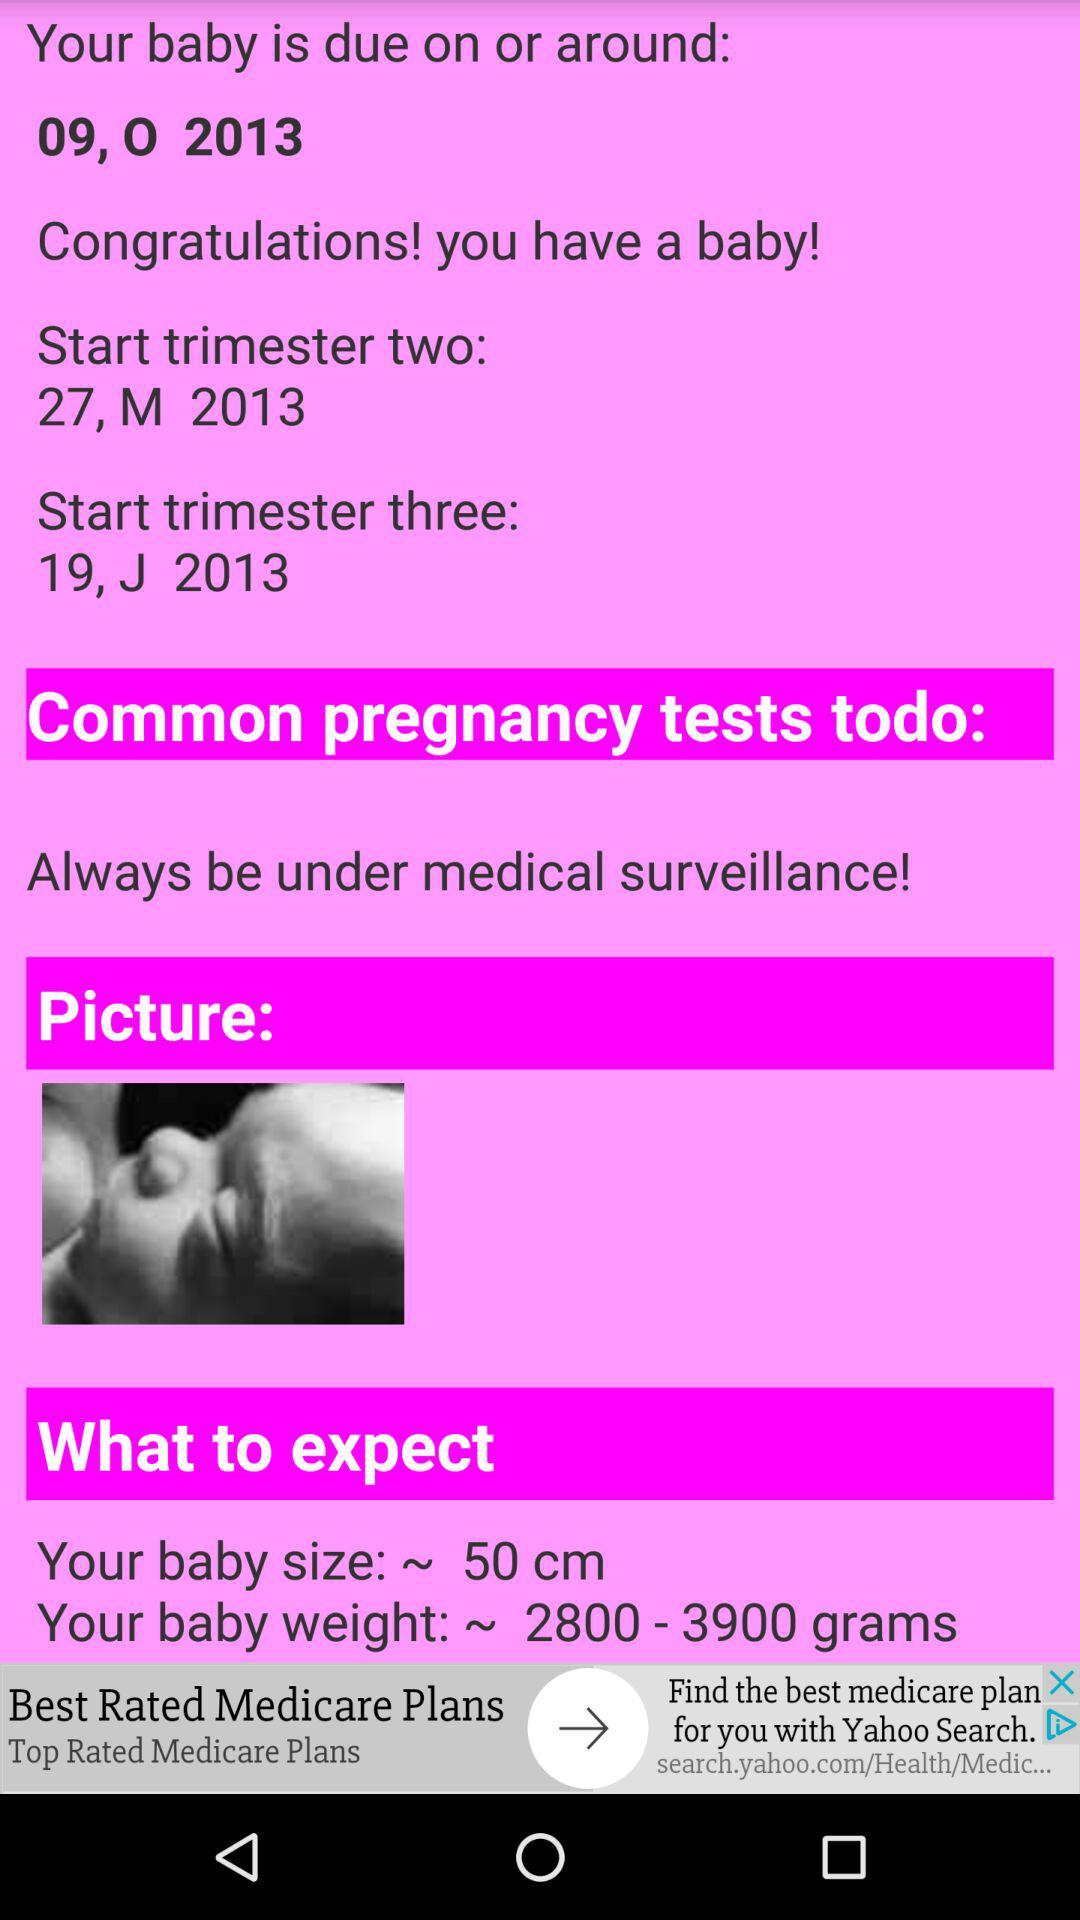When does trimester three begin? Trimester three begins on "19, J 2013". 